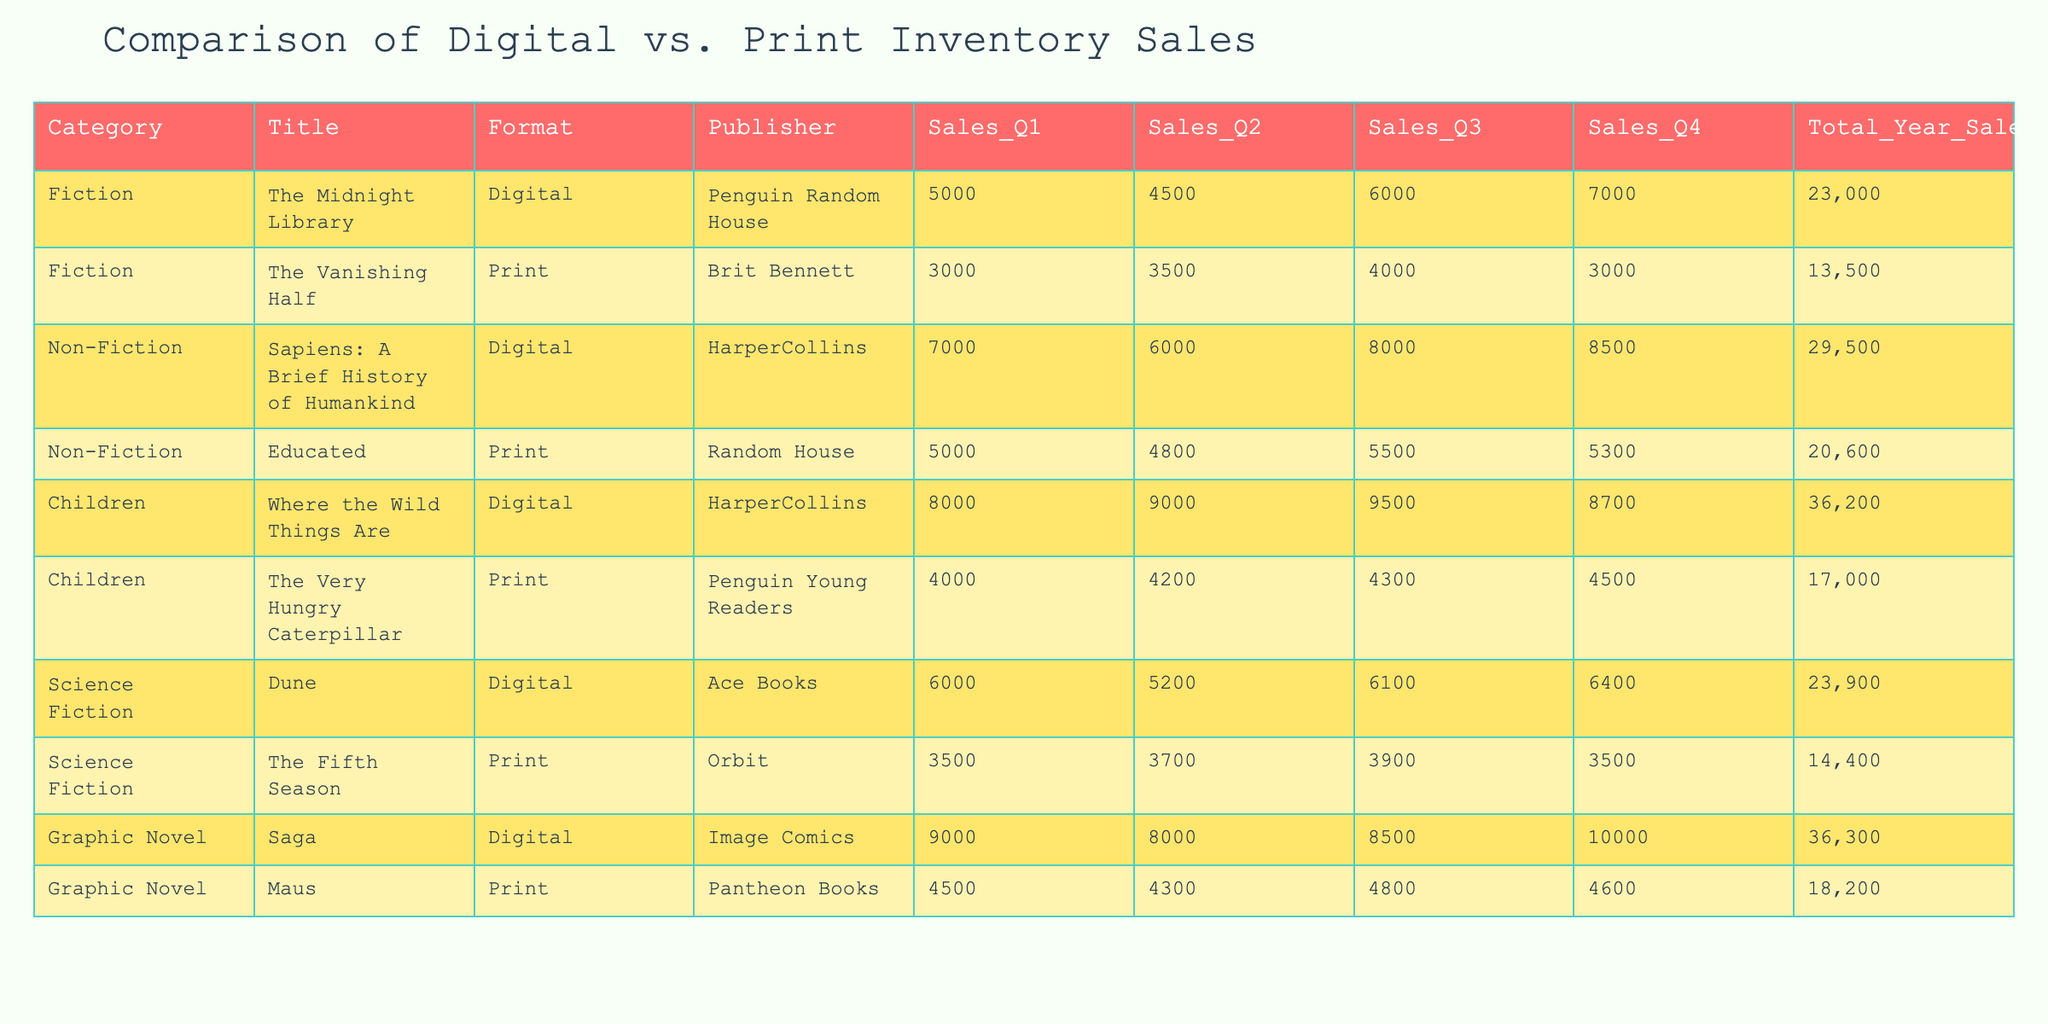What is the total sales for "Where the Wild Things Are"? The total sales figure is clearly stated in the table under the "Total_Year_Sales" column next to "Where the Wild Things Are". The total is 36200.
Answer: 36200 What format sold more copies, Digital or Print, in Q1? We compare the Q1 sales figures for both formats by looking at the "Sales_Q1" column. Adding the digital sales (5000 + 7000 + 8000 + 9000 + 9000 = 29000) and print sales (3000 + 5000 + 4000 + 4500 = 17000). Since 29000 > 17000, Digital sold more.
Answer: Digital Is the total sales of "The Midnight Library" greater than the total sales of "Educated"? We look at the "Total_Year_Sales" values for "The Midnight Library" (23000) and "Educated" (20600). Comparing these values, it’s clear that 23000 > 20600, hence the statement is true.
Answer: Yes What is the average sales for print format titles across all quarters? First, we extract the print sales data: 3000 + 3500 + 4000 + 3000 for "The Vanishing Half" and 5000 + 4800 + 5500 + 5300 for "Educated", 4000 + 4200 + 4300 + 4500 for "The Very Hungry Caterpillar" and 3500 + 3700 + 3900 + 3500 for "The Fifth Season" and 4500 + 4300 + 4800 + 4600 for "Maus". The total is 13500 + 20600 + 17000 + 14400 + 18200 = 101700. Dividing by the number of print titles (5), we find the average is 101700 / 5 = 20340.
Answer: 20340 Which title had the highest sales in Q3 and what were those sales? We review the "Sales_Q3" column for all titles. The highest sales figure is from "Where the Wild Things Are" with 9500 sales.
Answer: Where the Wild Things Are, 9500 